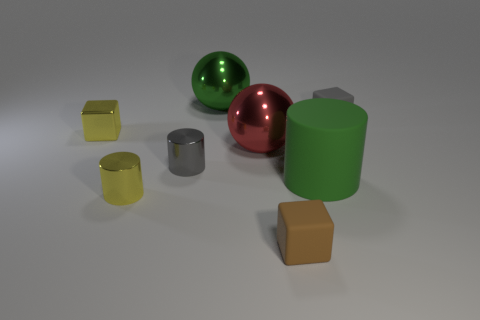Subtract all yellow cylinders. How many cylinders are left? 2 Add 2 big green shiny spheres. How many objects exist? 10 Subtract all gray cylinders. How many cylinders are left? 2 Subtract all spheres. How many objects are left? 6 Subtract 2 balls. How many balls are left? 0 Subtract all purple cubes. Subtract all gray balls. How many cubes are left? 3 Subtract all yellow cubes. Subtract all small gray cylinders. How many objects are left? 6 Add 3 metal balls. How many metal balls are left? 5 Add 8 small blue matte spheres. How many small blue matte spheres exist? 8 Subtract 1 gray cylinders. How many objects are left? 7 